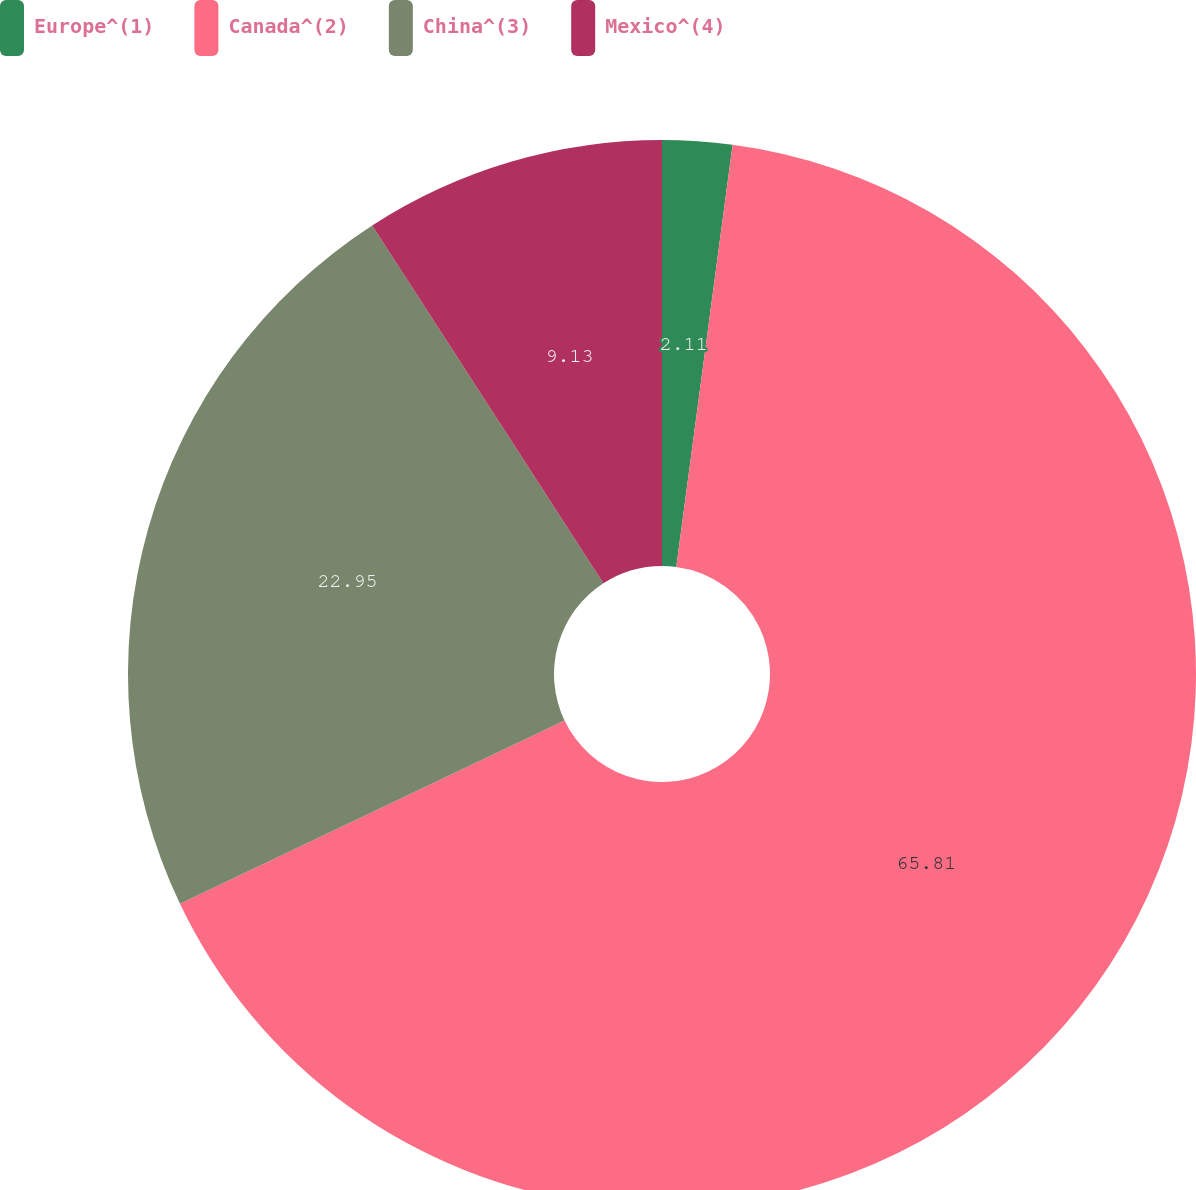Convert chart to OTSL. <chart><loc_0><loc_0><loc_500><loc_500><pie_chart><fcel>Europe^(1)<fcel>Canada^(2)<fcel>China^(3)<fcel>Mexico^(4)<nl><fcel>2.11%<fcel>65.81%<fcel>22.95%<fcel>9.13%<nl></chart> 